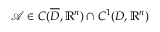Convert formula to latex. <formula><loc_0><loc_0><loc_500><loc_500>\mathcal { A } \in C ( \overline { D } , \mathbb { R } ^ { n } ) \cap C ^ { 1 } ( D , \mathbb { R } ^ { n } )</formula> 